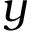<formula> <loc_0><loc_0><loc_500><loc_500>y</formula> 